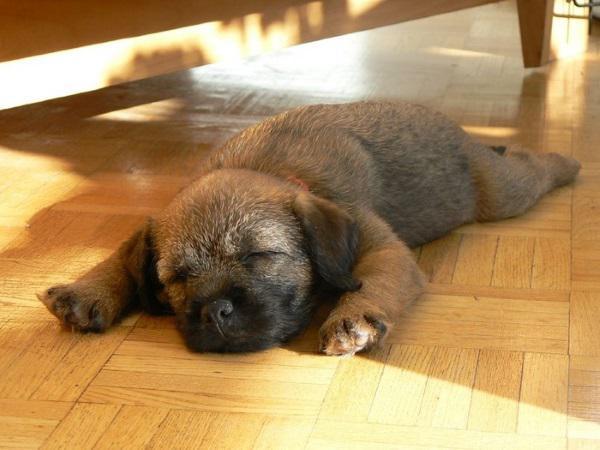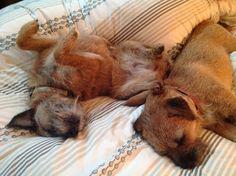The first image is the image on the left, the second image is the image on the right. Evaluate the accuracy of this statement regarding the images: "There are three dogs sleeping". Is it true? Answer yes or no. Yes. The first image is the image on the left, the second image is the image on the right. For the images displayed, is the sentence "There are no more than two dogs." factually correct? Answer yes or no. No. 